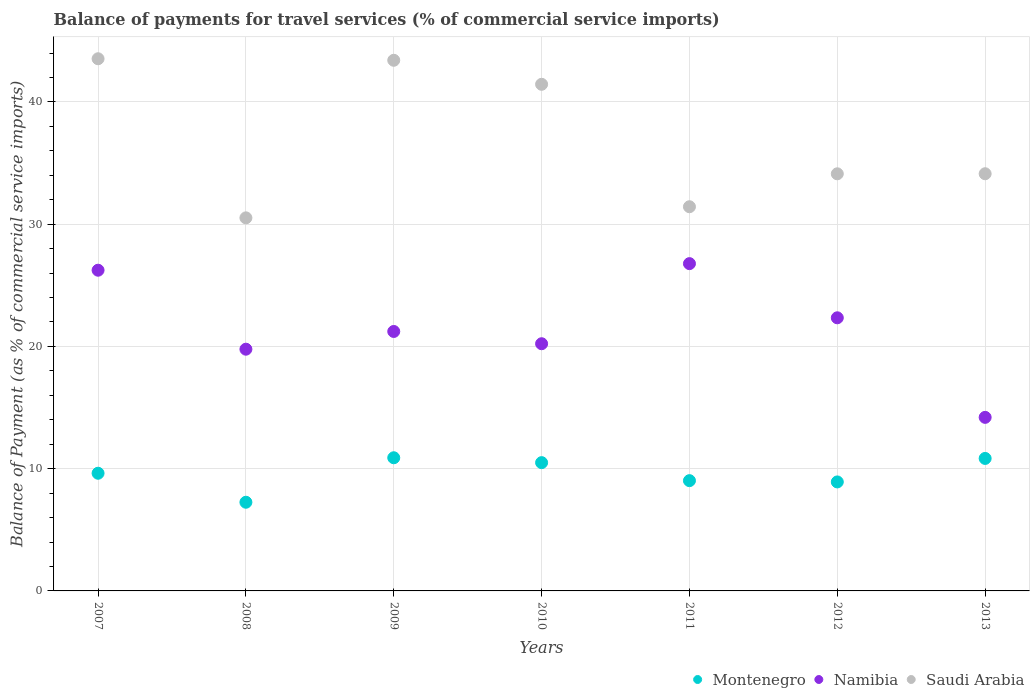How many different coloured dotlines are there?
Provide a short and direct response. 3. Is the number of dotlines equal to the number of legend labels?
Ensure brevity in your answer.  Yes. What is the balance of payments for travel services in Montenegro in 2007?
Provide a succinct answer. 9.63. Across all years, what is the maximum balance of payments for travel services in Montenegro?
Offer a terse response. 10.89. Across all years, what is the minimum balance of payments for travel services in Montenegro?
Your answer should be compact. 7.25. In which year was the balance of payments for travel services in Saudi Arabia minimum?
Offer a very short reply. 2008. What is the total balance of payments for travel services in Montenegro in the graph?
Provide a short and direct response. 67.04. What is the difference between the balance of payments for travel services in Namibia in 2007 and that in 2013?
Offer a terse response. 12.04. What is the difference between the balance of payments for travel services in Namibia in 2013 and the balance of payments for travel services in Saudi Arabia in 2008?
Keep it short and to the point. -16.32. What is the average balance of payments for travel services in Montenegro per year?
Your answer should be very brief. 9.58. In the year 2009, what is the difference between the balance of payments for travel services in Montenegro and balance of payments for travel services in Namibia?
Make the answer very short. -10.33. In how many years, is the balance of payments for travel services in Montenegro greater than 16 %?
Provide a succinct answer. 0. What is the ratio of the balance of payments for travel services in Saudi Arabia in 2012 to that in 2013?
Ensure brevity in your answer.  1. Is the difference between the balance of payments for travel services in Montenegro in 2007 and 2013 greater than the difference between the balance of payments for travel services in Namibia in 2007 and 2013?
Ensure brevity in your answer.  No. What is the difference between the highest and the second highest balance of payments for travel services in Montenegro?
Make the answer very short. 0.05. What is the difference between the highest and the lowest balance of payments for travel services in Namibia?
Give a very brief answer. 12.58. In how many years, is the balance of payments for travel services in Saudi Arabia greater than the average balance of payments for travel services in Saudi Arabia taken over all years?
Provide a short and direct response. 3. Does the balance of payments for travel services in Namibia monotonically increase over the years?
Your response must be concise. No. Is the balance of payments for travel services in Montenegro strictly greater than the balance of payments for travel services in Namibia over the years?
Make the answer very short. No. Is the balance of payments for travel services in Namibia strictly less than the balance of payments for travel services in Saudi Arabia over the years?
Make the answer very short. Yes. How many dotlines are there?
Your answer should be compact. 3. Are the values on the major ticks of Y-axis written in scientific E-notation?
Ensure brevity in your answer.  No. Does the graph contain any zero values?
Provide a short and direct response. No. Does the graph contain grids?
Give a very brief answer. Yes. Where does the legend appear in the graph?
Provide a succinct answer. Bottom right. How many legend labels are there?
Provide a succinct answer. 3. How are the legend labels stacked?
Ensure brevity in your answer.  Horizontal. What is the title of the graph?
Your answer should be very brief. Balance of payments for travel services (% of commercial service imports). Does "Angola" appear as one of the legend labels in the graph?
Your response must be concise. No. What is the label or title of the Y-axis?
Your answer should be very brief. Balance of Payment (as % of commercial service imports). What is the Balance of Payment (as % of commercial service imports) of Montenegro in 2007?
Provide a short and direct response. 9.63. What is the Balance of Payment (as % of commercial service imports) of Namibia in 2007?
Provide a short and direct response. 26.24. What is the Balance of Payment (as % of commercial service imports) in Saudi Arabia in 2007?
Make the answer very short. 43.53. What is the Balance of Payment (as % of commercial service imports) of Montenegro in 2008?
Your answer should be very brief. 7.25. What is the Balance of Payment (as % of commercial service imports) of Namibia in 2008?
Provide a short and direct response. 19.77. What is the Balance of Payment (as % of commercial service imports) in Saudi Arabia in 2008?
Your response must be concise. 30.52. What is the Balance of Payment (as % of commercial service imports) of Montenegro in 2009?
Ensure brevity in your answer.  10.89. What is the Balance of Payment (as % of commercial service imports) in Namibia in 2009?
Make the answer very short. 21.22. What is the Balance of Payment (as % of commercial service imports) of Saudi Arabia in 2009?
Provide a succinct answer. 43.41. What is the Balance of Payment (as % of commercial service imports) of Montenegro in 2010?
Your answer should be compact. 10.49. What is the Balance of Payment (as % of commercial service imports) in Namibia in 2010?
Provide a succinct answer. 20.22. What is the Balance of Payment (as % of commercial service imports) in Saudi Arabia in 2010?
Give a very brief answer. 41.44. What is the Balance of Payment (as % of commercial service imports) in Montenegro in 2011?
Provide a short and direct response. 9.02. What is the Balance of Payment (as % of commercial service imports) of Namibia in 2011?
Make the answer very short. 26.77. What is the Balance of Payment (as % of commercial service imports) in Saudi Arabia in 2011?
Your answer should be compact. 31.43. What is the Balance of Payment (as % of commercial service imports) in Montenegro in 2012?
Your response must be concise. 8.92. What is the Balance of Payment (as % of commercial service imports) of Namibia in 2012?
Keep it short and to the point. 22.34. What is the Balance of Payment (as % of commercial service imports) in Saudi Arabia in 2012?
Your answer should be very brief. 34.12. What is the Balance of Payment (as % of commercial service imports) of Montenegro in 2013?
Your answer should be very brief. 10.84. What is the Balance of Payment (as % of commercial service imports) of Namibia in 2013?
Your answer should be very brief. 14.2. What is the Balance of Payment (as % of commercial service imports) of Saudi Arabia in 2013?
Keep it short and to the point. 34.13. Across all years, what is the maximum Balance of Payment (as % of commercial service imports) of Montenegro?
Give a very brief answer. 10.89. Across all years, what is the maximum Balance of Payment (as % of commercial service imports) of Namibia?
Your answer should be very brief. 26.77. Across all years, what is the maximum Balance of Payment (as % of commercial service imports) of Saudi Arabia?
Give a very brief answer. 43.53. Across all years, what is the minimum Balance of Payment (as % of commercial service imports) of Montenegro?
Ensure brevity in your answer.  7.25. Across all years, what is the minimum Balance of Payment (as % of commercial service imports) of Namibia?
Provide a succinct answer. 14.2. Across all years, what is the minimum Balance of Payment (as % of commercial service imports) in Saudi Arabia?
Your answer should be very brief. 30.52. What is the total Balance of Payment (as % of commercial service imports) in Montenegro in the graph?
Provide a short and direct response. 67.04. What is the total Balance of Payment (as % of commercial service imports) in Namibia in the graph?
Give a very brief answer. 150.77. What is the total Balance of Payment (as % of commercial service imports) in Saudi Arabia in the graph?
Give a very brief answer. 258.59. What is the difference between the Balance of Payment (as % of commercial service imports) of Montenegro in 2007 and that in 2008?
Your response must be concise. 2.37. What is the difference between the Balance of Payment (as % of commercial service imports) of Namibia in 2007 and that in 2008?
Your answer should be very brief. 6.46. What is the difference between the Balance of Payment (as % of commercial service imports) of Saudi Arabia in 2007 and that in 2008?
Give a very brief answer. 13.02. What is the difference between the Balance of Payment (as % of commercial service imports) of Montenegro in 2007 and that in 2009?
Give a very brief answer. -1.27. What is the difference between the Balance of Payment (as % of commercial service imports) of Namibia in 2007 and that in 2009?
Your answer should be compact. 5.01. What is the difference between the Balance of Payment (as % of commercial service imports) of Saudi Arabia in 2007 and that in 2009?
Your response must be concise. 0.13. What is the difference between the Balance of Payment (as % of commercial service imports) in Montenegro in 2007 and that in 2010?
Provide a succinct answer. -0.87. What is the difference between the Balance of Payment (as % of commercial service imports) of Namibia in 2007 and that in 2010?
Your answer should be very brief. 6.01. What is the difference between the Balance of Payment (as % of commercial service imports) of Saudi Arabia in 2007 and that in 2010?
Give a very brief answer. 2.09. What is the difference between the Balance of Payment (as % of commercial service imports) in Montenegro in 2007 and that in 2011?
Your answer should be very brief. 0.61. What is the difference between the Balance of Payment (as % of commercial service imports) in Namibia in 2007 and that in 2011?
Provide a short and direct response. -0.54. What is the difference between the Balance of Payment (as % of commercial service imports) in Saudi Arabia in 2007 and that in 2011?
Ensure brevity in your answer.  12.11. What is the difference between the Balance of Payment (as % of commercial service imports) in Montenegro in 2007 and that in 2012?
Provide a succinct answer. 0.71. What is the difference between the Balance of Payment (as % of commercial service imports) of Namibia in 2007 and that in 2012?
Your answer should be very brief. 3.89. What is the difference between the Balance of Payment (as % of commercial service imports) of Saudi Arabia in 2007 and that in 2012?
Keep it short and to the point. 9.41. What is the difference between the Balance of Payment (as % of commercial service imports) of Montenegro in 2007 and that in 2013?
Ensure brevity in your answer.  -1.21. What is the difference between the Balance of Payment (as % of commercial service imports) in Namibia in 2007 and that in 2013?
Your answer should be compact. 12.04. What is the difference between the Balance of Payment (as % of commercial service imports) in Saudi Arabia in 2007 and that in 2013?
Ensure brevity in your answer.  9.41. What is the difference between the Balance of Payment (as % of commercial service imports) of Montenegro in 2008 and that in 2009?
Give a very brief answer. -3.64. What is the difference between the Balance of Payment (as % of commercial service imports) of Namibia in 2008 and that in 2009?
Give a very brief answer. -1.45. What is the difference between the Balance of Payment (as % of commercial service imports) of Saudi Arabia in 2008 and that in 2009?
Provide a short and direct response. -12.89. What is the difference between the Balance of Payment (as % of commercial service imports) of Montenegro in 2008 and that in 2010?
Your answer should be compact. -3.24. What is the difference between the Balance of Payment (as % of commercial service imports) of Namibia in 2008 and that in 2010?
Make the answer very short. -0.45. What is the difference between the Balance of Payment (as % of commercial service imports) in Saudi Arabia in 2008 and that in 2010?
Offer a terse response. -10.93. What is the difference between the Balance of Payment (as % of commercial service imports) in Montenegro in 2008 and that in 2011?
Your response must be concise. -1.77. What is the difference between the Balance of Payment (as % of commercial service imports) in Namibia in 2008 and that in 2011?
Keep it short and to the point. -7. What is the difference between the Balance of Payment (as % of commercial service imports) of Saudi Arabia in 2008 and that in 2011?
Provide a short and direct response. -0.91. What is the difference between the Balance of Payment (as % of commercial service imports) of Montenegro in 2008 and that in 2012?
Make the answer very short. -1.66. What is the difference between the Balance of Payment (as % of commercial service imports) in Namibia in 2008 and that in 2012?
Keep it short and to the point. -2.57. What is the difference between the Balance of Payment (as % of commercial service imports) of Saudi Arabia in 2008 and that in 2012?
Keep it short and to the point. -3.6. What is the difference between the Balance of Payment (as % of commercial service imports) in Montenegro in 2008 and that in 2013?
Provide a short and direct response. -3.58. What is the difference between the Balance of Payment (as % of commercial service imports) in Namibia in 2008 and that in 2013?
Offer a very short reply. 5.58. What is the difference between the Balance of Payment (as % of commercial service imports) of Saudi Arabia in 2008 and that in 2013?
Give a very brief answer. -3.61. What is the difference between the Balance of Payment (as % of commercial service imports) in Montenegro in 2009 and that in 2010?
Your response must be concise. 0.4. What is the difference between the Balance of Payment (as % of commercial service imports) of Namibia in 2009 and that in 2010?
Your answer should be very brief. 1. What is the difference between the Balance of Payment (as % of commercial service imports) in Saudi Arabia in 2009 and that in 2010?
Your answer should be compact. 1.96. What is the difference between the Balance of Payment (as % of commercial service imports) of Montenegro in 2009 and that in 2011?
Give a very brief answer. 1.87. What is the difference between the Balance of Payment (as % of commercial service imports) in Namibia in 2009 and that in 2011?
Give a very brief answer. -5.55. What is the difference between the Balance of Payment (as % of commercial service imports) of Saudi Arabia in 2009 and that in 2011?
Your response must be concise. 11.98. What is the difference between the Balance of Payment (as % of commercial service imports) in Montenegro in 2009 and that in 2012?
Your response must be concise. 1.98. What is the difference between the Balance of Payment (as % of commercial service imports) in Namibia in 2009 and that in 2012?
Your answer should be very brief. -1.12. What is the difference between the Balance of Payment (as % of commercial service imports) in Saudi Arabia in 2009 and that in 2012?
Keep it short and to the point. 9.29. What is the difference between the Balance of Payment (as % of commercial service imports) in Montenegro in 2009 and that in 2013?
Keep it short and to the point. 0.05. What is the difference between the Balance of Payment (as % of commercial service imports) of Namibia in 2009 and that in 2013?
Provide a short and direct response. 7.03. What is the difference between the Balance of Payment (as % of commercial service imports) in Saudi Arabia in 2009 and that in 2013?
Make the answer very short. 9.28. What is the difference between the Balance of Payment (as % of commercial service imports) of Montenegro in 2010 and that in 2011?
Your response must be concise. 1.47. What is the difference between the Balance of Payment (as % of commercial service imports) of Namibia in 2010 and that in 2011?
Make the answer very short. -6.55. What is the difference between the Balance of Payment (as % of commercial service imports) in Saudi Arabia in 2010 and that in 2011?
Your answer should be compact. 10.02. What is the difference between the Balance of Payment (as % of commercial service imports) of Montenegro in 2010 and that in 2012?
Make the answer very short. 1.58. What is the difference between the Balance of Payment (as % of commercial service imports) of Namibia in 2010 and that in 2012?
Your response must be concise. -2.12. What is the difference between the Balance of Payment (as % of commercial service imports) in Saudi Arabia in 2010 and that in 2012?
Give a very brief answer. 7.32. What is the difference between the Balance of Payment (as % of commercial service imports) of Montenegro in 2010 and that in 2013?
Keep it short and to the point. -0.35. What is the difference between the Balance of Payment (as % of commercial service imports) in Namibia in 2010 and that in 2013?
Ensure brevity in your answer.  6.02. What is the difference between the Balance of Payment (as % of commercial service imports) of Saudi Arabia in 2010 and that in 2013?
Your answer should be very brief. 7.32. What is the difference between the Balance of Payment (as % of commercial service imports) in Montenegro in 2011 and that in 2012?
Provide a short and direct response. 0.1. What is the difference between the Balance of Payment (as % of commercial service imports) of Namibia in 2011 and that in 2012?
Provide a succinct answer. 4.43. What is the difference between the Balance of Payment (as % of commercial service imports) in Saudi Arabia in 2011 and that in 2012?
Provide a short and direct response. -2.69. What is the difference between the Balance of Payment (as % of commercial service imports) in Montenegro in 2011 and that in 2013?
Offer a very short reply. -1.82. What is the difference between the Balance of Payment (as % of commercial service imports) in Namibia in 2011 and that in 2013?
Make the answer very short. 12.58. What is the difference between the Balance of Payment (as % of commercial service imports) in Saudi Arabia in 2011 and that in 2013?
Make the answer very short. -2.7. What is the difference between the Balance of Payment (as % of commercial service imports) in Montenegro in 2012 and that in 2013?
Offer a terse response. -1.92. What is the difference between the Balance of Payment (as % of commercial service imports) in Namibia in 2012 and that in 2013?
Keep it short and to the point. 8.14. What is the difference between the Balance of Payment (as % of commercial service imports) of Saudi Arabia in 2012 and that in 2013?
Offer a very short reply. -0.01. What is the difference between the Balance of Payment (as % of commercial service imports) in Montenegro in 2007 and the Balance of Payment (as % of commercial service imports) in Namibia in 2008?
Provide a succinct answer. -10.15. What is the difference between the Balance of Payment (as % of commercial service imports) in Montenegro in 2007 and the Balance of Payment (as % of commercial service imports) in Saudi Arabia in 2008?
Keep it short and to the point. -20.89. What is the difference between the Balance of Payment (as % of commercial service imports) in Namibia in 2007 and the Balance of Payment (as % of commercial service imports) in Saudi Arabia in 2008?
Offer a terse response. -4.28. What is the difference between the Balance of Payment (as % of commercial service imports) of Montenegro in 2007 and the Balance of Payment (as % of commercial service imports) of Namibia in 2009?
Give a very brief answer. -11.6. What is the difference between the Balance of Payment (as % of commercial service imports) of Montenegro in 2007 and the Balance of Payment (as % of commercial service imports) of Saudi Arabia in 2009?
Give a very brief answer. -33.78. What is the difference between the Balance of Payment (as % of commercial service imports) of Namibia in 2007 and the Balance of Payment (as % of commercial service imports) of Saudi Arabia in 2009?
Keep it short and to the point. -17.17. What is the difference between the Balance of Payment (as % of commercial service imports) in Montenegro in 2007 and the Balance of Payment (as % of commercial service imports) in Namibia in 2010?
Provide a succinct answer. -10.59. What is the difference between the Balance of Payment (as % of commercial service imports) in Montenegro in 2007 and the Balance of Payment (as % of commercial service imports) in Saudi Arabia in 2010?
Your answer should be compact. -31.82. What is the difference between the Balance of Payment (as % of commercial service imports) of Namibia in 2007 and the Balance of Payment (as % of commercial service imports) of Saudi Arabia in 2010?
Ensure brevity in your answer.  -15.21. What is the difference between the Balance of Payment (as % of commercial service imports) of Montenegro in 2007 and the Balance of Payment (as % of commercial service imports) of Namibia in 2011?
Make the answer very short. -17.15. What is the difference between the Balance of Payment (as % of commercial service imports) of Montenegro in 2007 and the Balance of Payment (as % of commercial service imports) of Saudi Arabia in 2011?
Keep it short and to the point. -21.8. What is the difference between the Balance of Payment (as % of commercial service imports) of Namibia in 2007 and the Balance of Payment (as % of commercial service imports) of Saudi Arabia in 2011?
Give a very brief answer. -5.19. What is the difference between the Balance of Payment (as % of commercial service imports) in Montenegro in 2007 and the Balance of Payment (as % of commercial service imports) in Namibia in 2012?
Ensure brevity in your answer.  -12.72. What is the difference between the Balance of Payment (as % of commercial service imports) in Montenegro in 2007 and the Balance of Payment (as % of commercial service imports) in Saudi Arabia in 2012?
Make the answer very short. -24.5. What is the difference between the Balance of Payment (as % of commercial service imports) in Namibia in 2007 and the Balance of Payment (as % of commercial service imports) in Saudi Arabia in 2012?
Provide a succinct answer. -7.89. What is the difference between the Balance of Payment (as % of commercial service imports) of Montenegro in 2007 and the Balance of Payment (as % of commercial service imports) of Namibia in 2013?
Your answer should be very brief. -4.57. What is the difference between the Balance of Payment (as % of commercial service imports) of Montenegro in 2007 and the Balance of Payment (as % of commercial service imports) of Saudi Arabia in 2013?
Keep it short and to the point. -24.5. What is the difference between the Balance of Payment (as % of commercial service imports) of Namibia in 2007 and the Balance of Payment (as % of commercial service imports) of Saudi Arabia in 2013?
Give a very brief answer. -7.89. What is the difference between the Balance of Payment (as % of commercial service imports) in Montenegro in 2008 and the Balance of Payment (as % of commercial service imports) in Namibia in 2009?
Your response must be concise. -13.97. What is the difference between the Balance of Payment (as % of commercial service imports) of Montenegro in 2008 and the Balance of Payment (as % of commercial service imports) of Saudi Arabia in 2009?
Provide a succinct answer. -36.16. What is the difference between the Balance of Payment (as % of commercial service imports) in Namibia in 2008 and the Balance of Payment (as % of commercial service imports) in Saudi Arabia in 2009?
Provide a short and direct response. -23.63. What is the difference between the Balance of Payment (as % of commercial service imports) of Montenegro in 2008 and the Balance of Payment (as % of commercial service imports) of Namibia in 2010?
Give a very brief answer. -12.97. What is the difference between the Balance of Payment (as % of commercial service imports) of Montenegro in 2008 and the Balance of Payment (as % of commercial service imports) of Saudi Arabia in 2010?
Give a very brief answer. -34.19. What is the difference between the Balance of Payment (as % of commercial service imports) of Namibia in 2008 and the Balance of Payment (as % of commercial service imports) of Saudi Arabia in 2010?
Make the answer very short. -21.67. What is the difference between the Balance of Payment (as % of commercial service imports) of Montenegro in 2008 and the Balance of Payment (as % of commercial service imports) of Namibia in 2011?
Your response must be concise. -19.52. What is the difference between the Balance of Payment (as % of commercial service imports) of Montenegro in 2008 and the Balance of Payment (as % of commercial service imports) of Saudi Arabia in 2011?
Give a very brief answer. -24.17. What is the difference between the Balance of Payment (as % of commercial service imports) in Namibia in 2008 and the Balance of Payment (as % of commercial service imports) in Saudi Arabia in 2011?
Your answer should be very brief. -11.65. What is the difference between the Balance of Payment (as % of commercial service imports) of Montenegro in 2008 and the Balance of Payment (as % of commercial service imports) of Namibia in 2012?
Offer a very short reply. -15.09. What is the difference between the Balance of Payment (as % of commercial service imports) in Montenegro in 2008 and the Balance of Payment (as % of commercial service imports) in Saudi Arabia in 2012?
Your response must be concise. -26.87. What is the difference between the Balance of Payment (as % of commercial service imports) of Namibia in 2008 and the Balance of Payment (as % of commercial service imports) of Saudi Arabia in 2012?
Keep it short and to the point. -14.35. What is the difference between the Balance of Payment (as % of commercial service imports) of Montenegro in 2008 and the Balance of Payment (as % of commercial service imports) of Namibia in 2013?
Keep it short and to the point. -6.94. What is the difference between the Balance of Payment (as % of commercial service imports) of Montenegro in 2008 and the Balance of Payment (as % of commercial service imports) of Saudi Arabia in 2013?
Your answer should be compact. -26.87. What is the difference between the Balance of Payment (as % of commercial service imports) of Namibia in 2008 and the Balance of Payment (as % of commercial service imports) of Saudi Arabia in 2013?
Give a very brief answer. -14.35. What is the difference between the Balance of Payment (as % of commercial service imports) of Montenegro in 2009 and the Balance of Payment (as % of commercial service imports) of Namibia in 2010?
Your response must be concise. -9.33. What is the difference between the Balance of Payment (as % of commercial service imports) of Montenegro in 2009 and the Balance of Payment (as % of commercial service imports) of Saudi Arabia in 2010?
Make the answer very short. -30.55. What is the difference between the Balance of Payment (as % of commercial service imports) in Namibia in 2009 and the Balance of Payment (as % of commercial service imports) in Saudi Arabia in 2010?
Make the answer very short. -20.22. What is the difference between the Balance of Payment (as % of commercial service imports) in Montenegro in 2009 and the Balance of Payment (as % of commercial service imports) in Namibia in 2011?
Provide a succinct answer. -15.88. What is the difference between the Balance of Payment (as % of commercial service imports) of Montenegro in 2009 and the Balance of Payment (as % of commercial service imports) of Saudi Arabia in 2011?
Your response must be concise. -20.54. What is the difference between the Balance of Payment (as % of commercial service imports) of Namibia in 2009 and the Balance of Payment (as % of commercial service imports) of Saudi Arabia in 2011?
Ensure brevity in your answer.  -10.2. What is the difference between the Balance of Payment (as % of commercial service imports) of Montenegro in 2009 and the Balance of Payment (as % of commercial service imports) of Namibia in 2012?
Make the answer very short. -11.45. What is the difference between the Balance of Payment (as % of commercial service imports) of Montenegro in 2009 and the Balance of Payment (as % of commercial service imports) of Saudi Arabia in 2012?
Your answer should be compact. -23.23. What is the difference between the Balance of Payment (as % of commercial service imports) in Namibia in 2009 and the Balance of Payment (as % of commercial service imports) in Saudi Arabia in 2012?
Your answer should be compact. -12.9. What is the difference between the Balance of Payment (as % of commercial service imports) of Montenegro in 2009 and the Balance of Payment (as % of commercial service imports) of Namibia in 2013?
Your response must be concise. -3.3. What is the difference between the Balance of Payment (as % of commercial service imports) in Montenegro in 2009 and the Balance of Payment (as % of commercial service imports) in Saudi Arabia in 2013?
Your answer should be compact. -23.23. What is the difference between the Balance of Payment (as % of commercial service imports) in Namibia in 2009 and the Balance of Payment (as % of commercial service imports) in Saudi Arabia in 2013?
Your answer should be very brief. -12.9. What is the difference between the Balance of Payment (as % of commercial service imports) of Montenegro in 2010 and the Balance of Payment (as % of commercial service imports) of Namibia in 2011?
Keep it short and to the point. -16.28. What is the difference between the Balance of Payment (as % of commercial service imports) in Montenegro in 2010 and the Balance of Payment (as % of commercial service imports) in Saudi Arabia in 2011?
Offer a very short reply. -20.93. What is the difference between the Balance of Payment (as % of commercial service imports) of Namibia in 2010 and the Balance of Payment (as % of commercial service imports) of Saudi Arabia in 2011?
Offer a very short reply. -11.21. What is the difference between the Balance of Payment (as % of commercial service imports) of Montenegro in 2010 and the Balance of Payment (as % of commercial service imports) of Namibia in 2012?
Make the answer very short. -11.85. What is the difference between the Balance of Payment (as % of commercial service imports) in Montenegro in 2010 and the Balance of Payment (as % of commercial service imports) in Saudi Arabia in 2012?
Ensure brevity in your answer.  -23.63. What is the difference between the Balance of Payment (as % of commercial service imports) of Namibia in 2010 and the Balance of Payment (as % of commercial service imports) of Saudi Arabia in 2012?
Provide a short and direct response. -13.9. What is the difference between the Balance of Payment (as % of commercial service imports) in Montenegro in 2010 and the Balance of Payment (as % of commercial service imports) in Namibia in 2013?
Keep it short and to the point. -3.7. What is the difference between the Balance of Payment (as % of commercial service imports) of Montenegro in 2010 and the Balance of Payment (as % of commercial service imports) of Saudi Arabia in 2013?
Your answer should be compact. -23.63. What is the difference between the Balance of Payment (as % of commercial service imports) in Namibia in 2010 and the Balance of Payment (as % of commercial service imports) in Saudi Arabia in 2013?
Your answer should be very brief. -13.91. What is the difference between the Balance of Payment (as % of commercial service imports) in Montenegro in 2011 and the Balance of Payment (as % of commercial service imports) in Namibia in 2012?
Your answer should be very brief. -13.32. What is the difference between the Balance of Payment (as % of commercial service imports) of Montenegro in 2011 and the Balance of Payment (as % of commercial service imports) of Saudi Arabia in 2012?
Ensure brevity in your answer.  -25.1. What is the difference between the Balance of Payment (as % of commercial service imports) in Namibia in 2011 and the Balance of Payment (as % of commercial service imports) in Saudi Arabia in 2012?
Give a very brief answer. -7.35. What is the difference between the Balance of Payment (as % of commercial service imports) of Montenegro in 2011 and the Balance of Payment (as % of commercial service imports) of Namibia in 2013?
Your answer should be compact. -5.18. What is the difference between the Balance of Payment (as % of commercial service imports) in Montenegro in 2011 and the Balance of Payment (as % of commercial service imports) in Saudi Arabia in 2013?
Provide a succinct answer. -25.11. What is the difference between the Balance of Payment (as % of commercial service imports) of Namibia in 2011 and the Balance of Payment (as % of commercial service imports) of Saudi Arabia in 2013?
Your answer should be compact. -7.35. What is the difference between the Balance of Payment (as % of commercial service imports) in Montenegro in 2012 and the Balance of Payment (as % of commercial service imports) in Namibia in 2013?
Give a very brief answer. -5.28. What is the difference between the Balance of Payment (as % of commercial service imports) in Montenegro in 2012 and the Balance of Payment (as % of commercial service imports) in Saudi Arabia in 2013?
Keep it short and to the point. -25.21. What is the difference between the Balance of Payment (as % of commercial service imports) of Namibia in 2012 and the Balance of Payment (as % of commercial service imports) of Saudi Arabia in 2013?
Provide a succinct answer. -11.79. What is the average Balance of Payment (as % of commercial service imports) in Montenegro per year?
Give a very brief answer. 9.58. What is the average Balance of Payment (as % of commercial service imports) of Namibia per year?
Your response must be concise. 21.54. What is the average Balance of Payment (as % of commercial service imports) of Saudi Arabia per year?
Give a very brief answer. 36.94. In the year 2007, what is the difference between the Balance of Payment (as % of commercial service imports) in Montenegro and Balance of Payment (as % of commercial service imports) in Namibia?
Ensure brevity in your answer.  -16.61. In the year 2007, what is the difference between the Balance of Payment (as % of commercial service imports) of Montenegro and Balance of Payment (as % of commercial service imports) of Saudi Arabia?
Offer a very short reply. -33.91. In the year 2007, what is the difference between the Balance of Payment (as % of commercial service imports) of Namibia and Balance of Payment (as % of commercial service imports) of Saudi Arabia?
Keep it short and to the point. -17.3. In the year 2008, what is the difference between the Balance of Payment (as % of commercial service imports) of Montenegro and Balance of Payment (as % of commercial service imports) of Namibia?
Offer a very short reply. -12.52. In the year 2008, what is the difference between the Balance of Payment (as % of commercial service imports) of Montenegro and Balance of Payment (as % of commercial service imports) of Saudi Arabia?
Make the answer very short. -23.27. In the year 2008, what is the difference between the Balance of Payment (as % of commercial service imports) of Namibia and Balance of Payment (as % of commercial service imports) of Saudi Arabia?
Offer a terse response. -10.74. In the year 2009, what is the difference between the Balance of Payment (as % of commercial service imports) of Montenegro and Balance of Payment (as % of commercial service imports) of Namibia?
Ensure brevity in your answer.  -10.33. In the year 2009, what is the difference between the Balance of Payment (as % of commercial service imports) in Montenegro and Balance of Payment (as % of commercial service imports) in Saudi Arabia?
Your answer should be compact. -32.52. In the year 2009, what is the difference between the Balance of Payment (as % of commercial service imports) in Namibia and Balance of Payment (as % of commercial service imports) in Saudi Arabia?
Provide a succinct answer. -22.18. In the year 2010, what is the difference between the Balance of Payment (as % of commercial service imports) of Montenegro and Balance of Payment (as % of commercial service imports) of Namibia?
Make the answer very short. -9.73. In the year 2010, what is the difference between the Balance of Payment (as % of commercial service imports) of Montenegro and Balance of Payment (as % of commercial service imports) of Saudi Arabia?
Ensure brevity in your answer.  -30.95. In the year 2010, what is the difference between the Balance of Payment (as % of commercial service imports) in Namibia and Balance of Payment (as % of commercial service imports) in Saudi Arabia?
Make the answer very short. -21.22. In the year 2011, what is the difference between the Balance of Payment (as % of commercial service imports) in Montenegro and Balance of Payment (as % of commercial service imports) in Namibia?
Provide a succinct answer. -17.75. In the year 2011, what is the difference between the Balance of Payment (as % of commercial service imports) in Montenegro and Balance of Payment (as % of commercial service imports) in Saudi Arabia?
Provide a short and direct response. -22.41. In the year 2011, what is the difference between the Balance of Payment (as % of commercial service imports) of Namibia and Balance of Payment (as % of commercial service imports) of Saudi Arabia?
Your answer should be very brief. -4.65. In the year 2012, what is the difference between the Balance of Payment (as % of commercial service imports) in Montenegro and Balance of Payment (as % of commercial service imports) in Namibia?
Your answer should be compact. -13.43. In the year 2012, what is the difference between the Balance of Payment (as % of commercial service imports) of Montenegro and Balance of Payment (as % of commercial service imports) of Saudi Arabia?
Your answer should be very brief. -25.21. In the year 2012, what is the difference between the Balance of Payment (as % of commercial service imports) in Namibia and Balance of Payment (as % of commercial service imports) in Saudi Arabia?
Provide a short and direct response. -11.78. In the year 2013, what is the difference between the Balance of Payment (as % of commercial service imports) in Montenegro and Balance of Payment (as % of commercial service imports) in Namibia?
Offer a terse response. -3.36. In the year 2013, what is the difference between the Balance of Payment (as % of commercial service imports) of Montenegro and Balance of Payment (as % of commercial service imports) of Saudi Arabia?
Offer a very short reply. -23.29. In the year 2013, what is the difference between the Balance of Payment (as % of commercial service imports) of Namibia and Balance of Payment (as % of commercial service imports) of Saudi Arabia?
Give a very brief answer. -19.93. What is the ratio of the Balance of Payment (as % of commercial service imports) of Montenegro in 2007 to that in 2008?
Ensure brevity in your answer.  1.33. What is the ratio of the Balance of Payment (as % of commercial service imports) of Namibia in 2007 to that in 2008?
Your answer should be very brief. 1.33. What is the ratio of the Balance of Payment (as % of commercial service imports) of Saudi Arabia in 2007 to that in 2008?
Make the answer very short. 1.43. What is the ratio of the Balance of Payment (as % of commercial service imports) of Montenegro in 2007 to that in 2009?
Provide a short and direct response. 0.88. What is the ratio of the Balance of Payment (as % of commercial service imports) in Namibia in 2007 to that in 2009?
Keep it short and to the point. 1.24. What is the ratio of the Balance of Payment (as % of commercial service imports) in Montenegro in 2007 to that in 2010?
Ensure brevity in your answer.  0.92. What is the ratio of the Balance of Payment (as % of commercial service imports) in Namibia in 2007 to that in 2010?
Give a very brief answer. 1.3. What is the ratio of the Balance of Payment (as % of commercial service imports) of Saudi Arabia in 2007 to that in 2010?
Offer a very short reply. 1.05. What is the ratio of the Balance of Payment (as % of commercial service imports) of Montenegro in 2007 to that in 2011?
Ensure brevity in your answer.  1.07. What is the ratio of the Balance of Payment (as % of commercial service imports) in Namibia in 2007 to that in 2011?
Ensure brevity in your answer.  0.98. What is the ratio of the Balance of Payment (as % of commercial service imports) of Saudi Arabia in 2007 to that in 2011?
Ensure brevity in your answer.  1.39. What is the ratio of the Balance of Payment (as % of commercial service imports) in Montenegro in 2007 to that in 2012?
Offer a very short reply. 1.08. What is the ratio of the Balance of Payment (as % of commercial service imports) in Namibia in 2007 to that in 2012?
Make the answer very short. 1.17. What is the ratio of the Balance of Payment (as % of commercial service imports) in Saudi Arabia in 2007 to that in 2012?
Your response must be concise. 1.28. What is the ratio of the Balance of Payment (as % of commercial service imports) in Montenegro in 2007 to that in 2013?
Provide a short and direct response. 0.89. What is the ratio of the Balance of Payment (as % of commercial service imports) in Namibia in 2007 to that in 2013?
Make the answer very short. 1.85. What is the ratio of the Balance of Payment (as % of commercial service imports) in Saudi Arabia in 2007 to that in 2013?
Your answer should be very brief. 1.28. What is the ratio of the Balance of Payment (as % of commercial service imports) in Montenegro in 2008 to that in 2009?
Your answer should be compact. 0.67. What is the ratio of the Balance of Payment (as % of commercial service imports) in Namibia in 2008 to that in 2009?
Your answer should be very brief. 0.93. What is the ratio of the Balance of Payment (as % of commercial service imports) of Saudi Arabia in 2008 to that in 2009?
Provide a succinct answer. 0.7. What is the ratio of the Balance of Payment (as % of commercial service imports) of Montenegro in 2008 to that in 2010?
Offer a terse response. 0.69. What is the ratio of the Balance of Payment (as % of commercial service imports) in Namibia in 2008 to that in 2010?
Your response must be concise. 0.98. What is the ratio of the Balance of Payment (as % of commercial service imports) in Saudi Arabia in 2008 to that in 2010?
Your answer should be compact. 0.74. What is the ratio of the Balance of Payment (as % of commercial service imports) of Montenegro in 2008 to that in 2011?
Your answer should be very brief. 0.8. What is the ratio of the Balance of Payment (as % of commercial service imports) in Namibia in 2008 to that in 2011?
Your answer should be very brief. 0.74. What is the ratio of the Balance of Payment (as % of commercial service imports) in Saudi Arabia in 2008 to that in 2011?
Offer a very short reply. 0.97. What is the ratio of the Balance of Payment (as % of commercial service imports) of Montenegro in 2008 to that in 2012?
Provide a succinct answer. 0.81. What is the ratio of the Balance of Payment (as % of commercial service imports) in Namibia in 2008 to that in 2012?
Your response must be concise. 0.89. What is the ratio of the Balance of Payment (as % of commercial service imports) in Saudi Arabia in 2008 to that in 2012?
Offer a very short reply. 0.89. What is the ratio of the Balance of Payment (as % of commercial service imports) of Montenegro in 2008 to that in 2013?
Your response must be concise. 0.67. What is the ratio of the Balance of Payment (as % of commercial service imports) in Namibia in 2008 to that in 2013?
Make the answer very short. 1.39. What is the ratio of the Balance of Payment (as % of commercial service imports) in Saudi Arabia in 2008 to that in 2013?
Provide a succinct answer. 0.89. What is the ratio of the Balance of Payment (as % of commercial service imports) in Montenegro in 2009 to that in 2010?
Give a very brief answer. 1.04. What is the ratio of the Balance of Payment (as % of commercial service imports) of Namibia in 2009 to that in 2010?
Your answer should be very brief. 1.05. What is the ratio of the Balance of Payment (as % of commercial service imports) in Saudi Arabia in 2009 to that in 2010?
Keep it short and to the point. 1.05. What is the ratio of the Balance of Payment (as % of commercial service imports) in Montenegro in 2009 to that in 2011?
Keep it short and to the point. 1.21. What is the ratio of the Balance of Payment (as % of commercial service imports) of Namibia in 2009 to that in 2011?
Your answer should be very brief. 0.79. What is the ratio of the Balance of Payment (as % of commercial service imports) of Saudi Arabia in 2009 to that in 2011?
Keep it short and to the point. 1.38. What is the ratio of the Balance of Payment (as % of commercial service imports) of Montenegro in 2009 to that in 2012?
Provide a short and direct response. 1.22. What is the ratio of the Balance of Payment (as % of commercial service imports) of Namibia in 2009 to that in 2012?
Give a very brief answer. 0.95. What is the ratio of the Balance of Payment (as % of commercial service imports) in Saudi Arabia in 2009 to that in 2012?
Ensure brevity in your answer.  1.27. What is the ratio of the Balance of Payment (as % of commercial service imports) of Montenegro in 2009 to that in 2013?
Provide a short and direct response. 1. What is the ratio of the Balance of Payment (as % of commercial service imports) in Namibia in 2009 to that in 2013?
Make the answer very short. 1.49. What is the ratio of the Balance of Payment (as % of commercial service imports) in Saudi Arabia in 2009 to that in 2013?
Provide a short and direct response. 1.27. What is the ratio of the Balance of Payment (as % of commercial service imports) in Montenegro in 2010 to that in 2011?
Your response must be concise. 1.16. What is the ratio of the Balance of Payment (as % of commercial service imports) in Namibia in 2010 to that in 2011?
Ensure brevity in your answer.  0.76. What is the ratio of the Balance of Payment (as % of commercial service imports) of Saudi Arabia in 2010 to that in 2011?
Give a very brief answer. 1.32. What is the ratio of the Balance of Payment (as % of commercial service imports) of Montenegro in 2010 to that in 2012?
Offer a very short reply. 1.18. What is the ratio of the Balance of Payment (as % of commercial service imports) in Namibia in 2010 to that in 2012?
Keep it short and to the point. 0.91. What is the ratio of the Balance of Payment (as % of commercial service imports) of Saudi Arabia in 2010 to that in 2012?
Provide a succinct answer. 1.21. What is the ratio of the Balance of Payment (as % of commercial service imports) in Montenegro in 2010 to that in 2013?
Give a very brief answer. 0.97. What is the ratio of the Balance of Payment (as % of commercial service imports) in Namibia in 2010 to that in 2013?
Give a very brief answer. 1.42. What is the ratio of the Balance of Payment (as % of commercial service imports) in Saudi Arabia in 2010 to that in 2013?
Make the answer very short. 1.21. What is the ratio of the Balance of Payment (as % of commercial service imports) in Montenegro in 2011 to that in 2012?
Provide a succinct answer. 1.01. What is the ratio of the Balance of Payment (as % of commercial service imports) of Namibia in 2011 to that in 2012?
Offer a terse response. 1.2. What is the ratio of the Balance of Payment (as % of commercial service imports) in Saudi Arabia in 2011 to that in 2012?
Ensure brevity in your answer.  0.92. What is the ratio of the Balance of Payment (as % of commercial service imports) in Montenegro in 2011 to that in 2013?
Provide a short and direct response. 0.83. What is the ratio of the Balance of Payment (as % of commercial service imports) in Namibia in 2011 to that in 2013?
Give a very brief answer. 1.89. What is the ratio of the Balance of Payment (as % of commercial service imports) in Saudi Arabia in 2011 to that in 2013?
Your answer should be compact. 0.92. What is the ratio of the Balance of Payment (as % of commercial service imports) in Montenegro in 2012 to that in 2013?
Provide a short and direct response. 0.82. What is the ratio of the Balance of Payment (as % of commercial service imports) of Namibia in 2012 to that in 2013?
Provide a short and direct response. 1.57. What is the difference between the highest and the second highest Balance of Payment (as % of commercial service imports) of Montenegro?
Make the answer very short. 0.05. What is the difference between the highest and the second highest Balance of Payment (as % of commercial service imports) of Namibia?
Your answer should be compact. 0.54. What is the difference between the highest and the second highest Balance of Payment (as % of commercial service imports) of Saudi Arabia?
Your answer should be very brief. 0.13. What is the difference between the highest and the lowest Balance of Payment (as % of commercial service imports) of Montenegro?
Give a very brief answer. 3.64. What is the difference between the highest and the lowest Balance of Payment (as % of commercial service imports) of Namibia?
Your response must be concise. 12.58. What is the difference between the highest and the lowest Balance of Payment (as % of commercial service imports) of Saudi Arabia?
Offer a terse response. 13.02. 